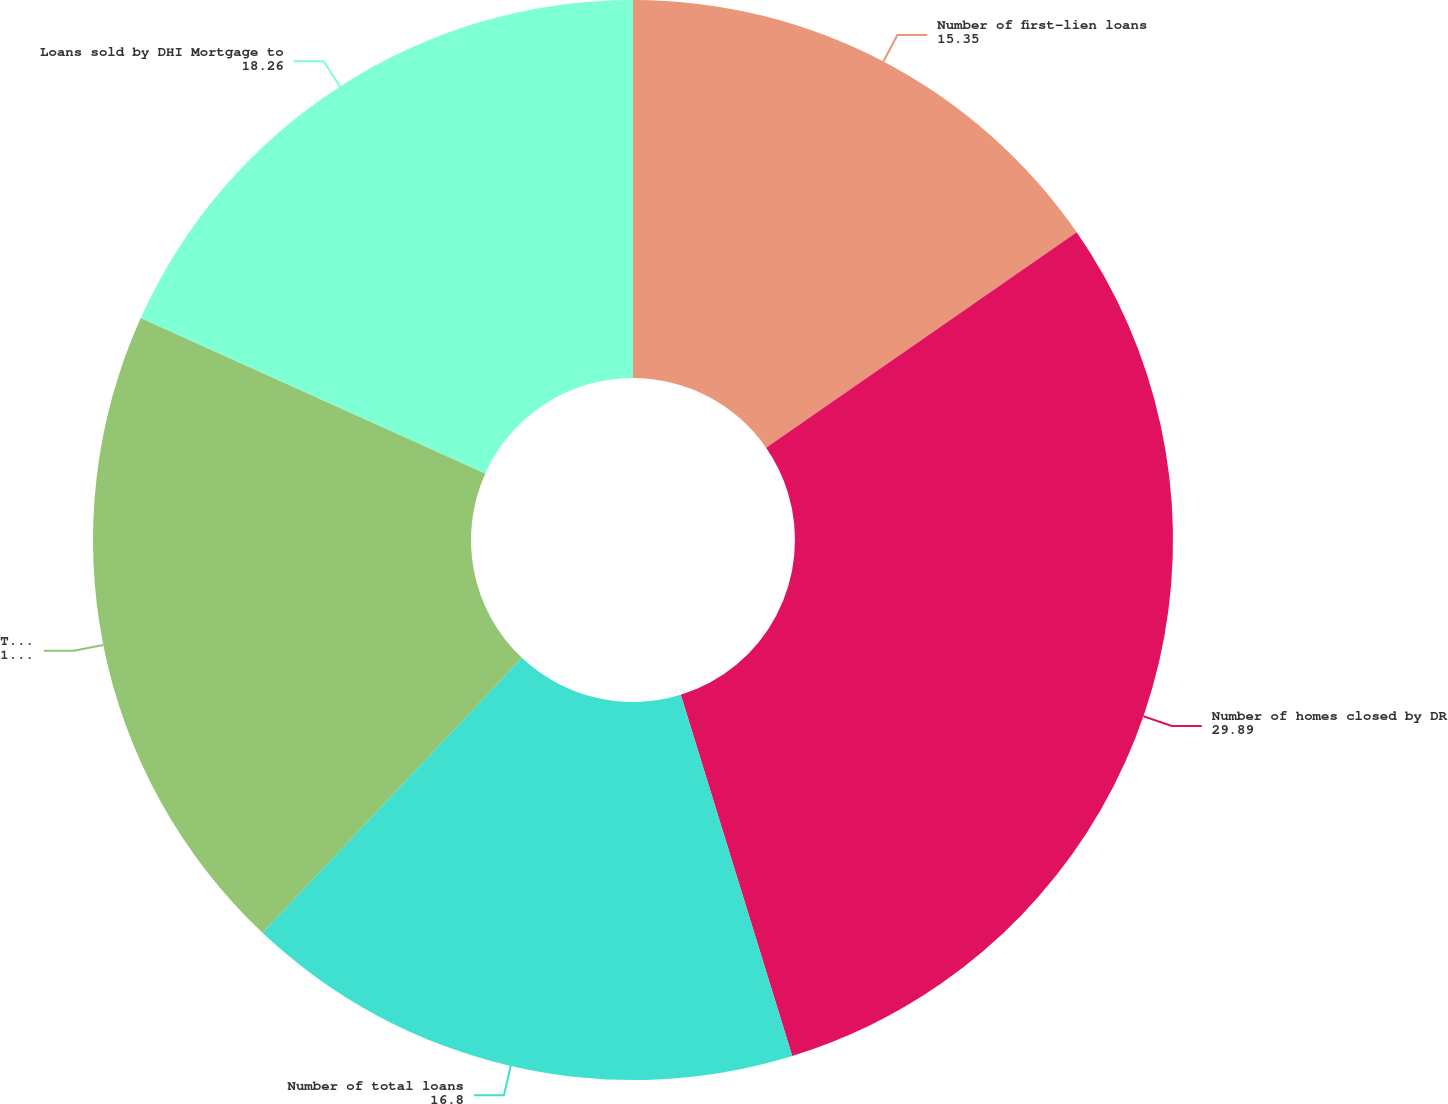Convert chart to OTSL. <chart><loc_0><loc_0><loc_500><loc_500><pie_chart><fcel>Number of first-lien loans<fcel>Number of homes closed by DR<fcel>Number of total loans<fcel>Total number of loans<fcel>Loans sold by DHI Mortgage to<nl><fcel>15.35%<fcel>29.89%<fcel>16.8%<fcel>19.71%<fcel>18.26%<nl></chart> 